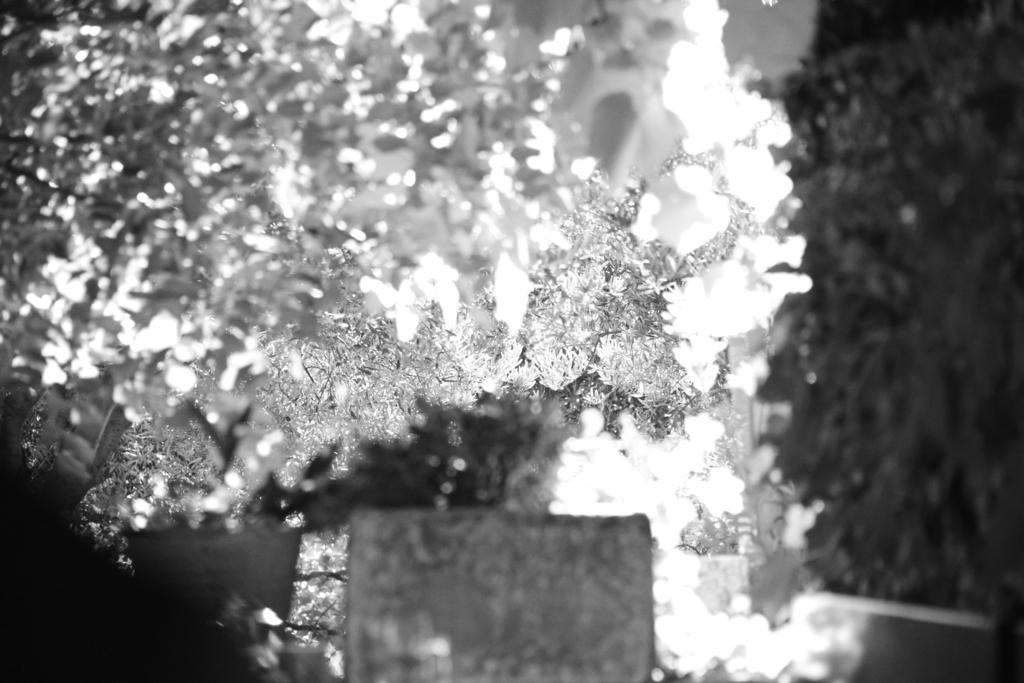What type of vegetation can be seen in the image? There are trees in the image. Can you describe the trees in the image? The provided facts do not give specific details about the trees, so we cannot describe them further. What is the setting of the image? The image features trees, which suggests a natural or outdoor setting. What color is the vest worn by the person in the image? There is no person or vest present in the image; it only features trees. 